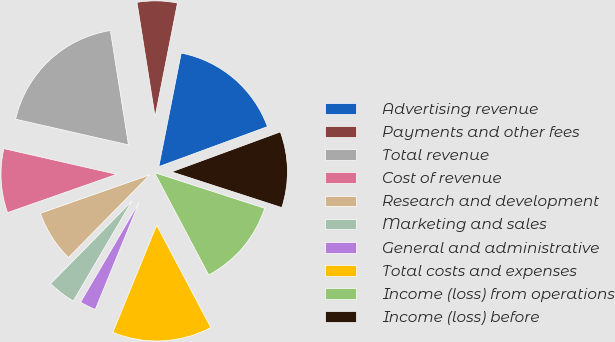Convert chart to OTSL. <chart><loc_0><loc_0><loc_500><loc_500><pie_chart><fcel>Advertising revenue<fcel>Payments and other fees<fcel>Total revenue<fcel>Cost of revenue<fcel>Research and development<fcel>Marketing and sales<fcel>General and administrative<fcel>Total costs and expenses<fcel>Income (loss) from operations<fcel>Income (loss) before<nl><fcel>16.29%<fcel>5.6%<fcel>18.93%<fcel>8.93%<fcel>7.26%<fcel>3.93%<fcel>2.26%<fcel>13.93%<fcel>12.26%<fcel>10.6%<nl></chart> 